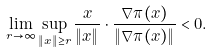<formula> <loc_0><loc_0><loc_500><loc_500>\lim _ { r \to \infty } \sup _ { \| x \| \geq r } \frac { x } { \| x \| } \cdot \frac { \nabla \pi ( x ) } { \| \nabla \pi ( x ) \| } < 0 .</formula> 